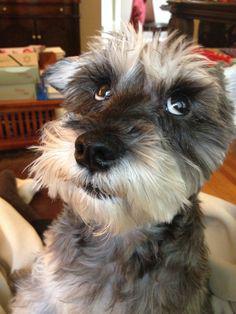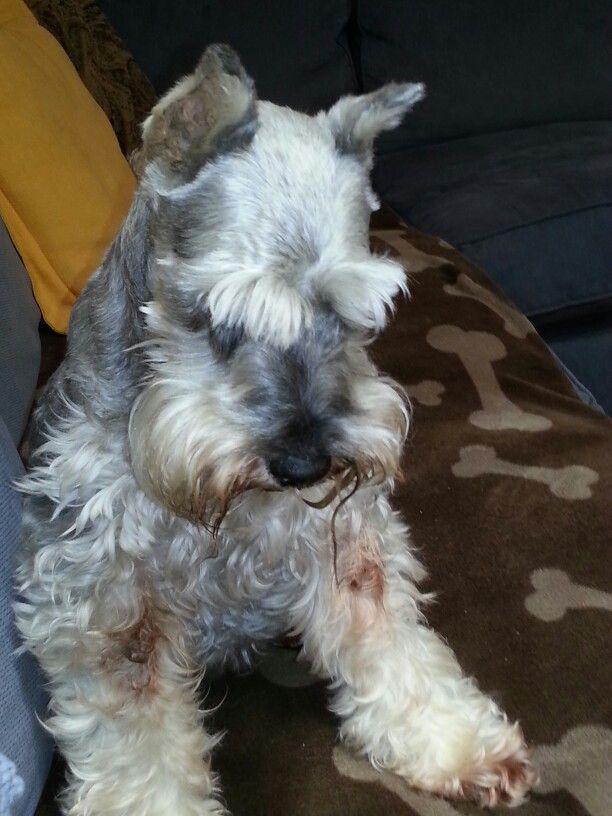The first image is the image on the left, the second image is the image on the right. Assess this claim about the two images: "Each image shows a schnauzer with light-colored 'mustache and beard' fur, and each dog faces the camera with eyes visible.". Correct or not? Answer yes or no. No. The first image is the image on the left, the second image is the image on the right. Analyze the images presented: Is the assertion "One of the dogs is wearing a round tag on its collar." valid? Answer yes or no. No. 